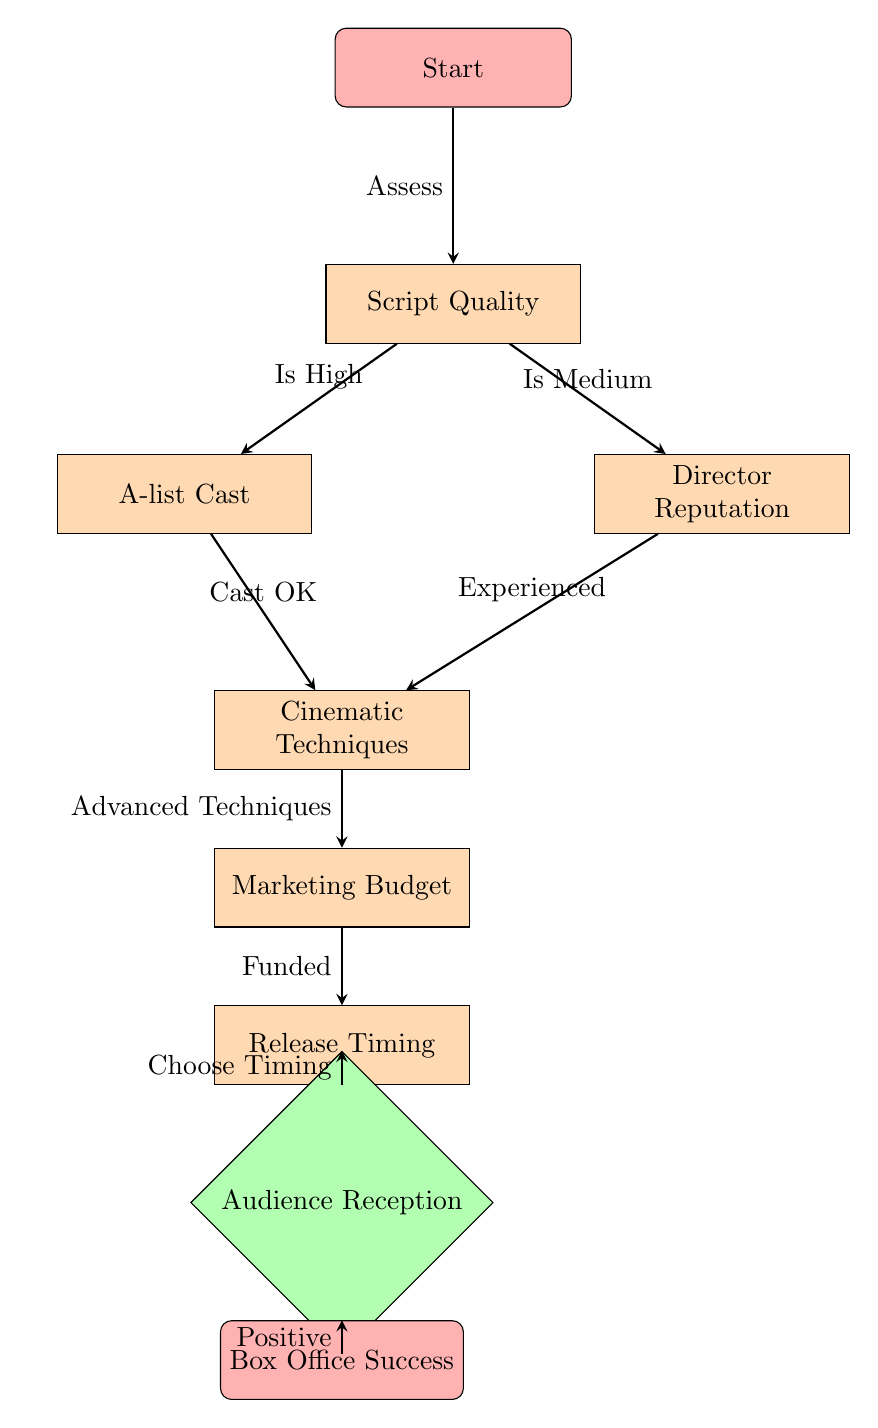What is the first step in the diagram? The first step is labeled as "Start." This is indicated at the top of the diagram and indicates the entry point of the process flow.
Answer: Start How many decision nodes are in the diagram? There is one decision node, titled "Audience Reception," which is found towards the bottom of the diagram. It signifies a point where a decision must be made.
Answer: 1 What happens after assessing script quality? After assessing script quality, the flow branches into two nodes based on its quality, leading to either "A-list Cast" or "Director Reputation." This indicates the subsequent factors to consider after script evaluation.
Answer: A-list Cast or Director Reputation What is required for positive audience reception? Positive audience reception is needed to achieve box office success, resulting in a link from the "Audience Reception" decision node to the "Box Office Success" outcome. This indicates that a favorable reception is crucial for overall success.
Answer: Positive If the script quality is high and the cast is okay, what is the next step? If the script quality is high, the flow leads to consider the "A-list Cast," which assesses whether the cast is acceptable before moving on to the "Cinematic Techniques." This shows a sequential consideration of various factors based on initial evaluations.
Answer: Cinematic Techniques What is the final outcome of the process flow? The end result of the diagram represents achieving "Box Office Success." This node is the ultimate goal derived from the successful evaluation of the previous nodes leading up to it.
Answer: Box Office Success 